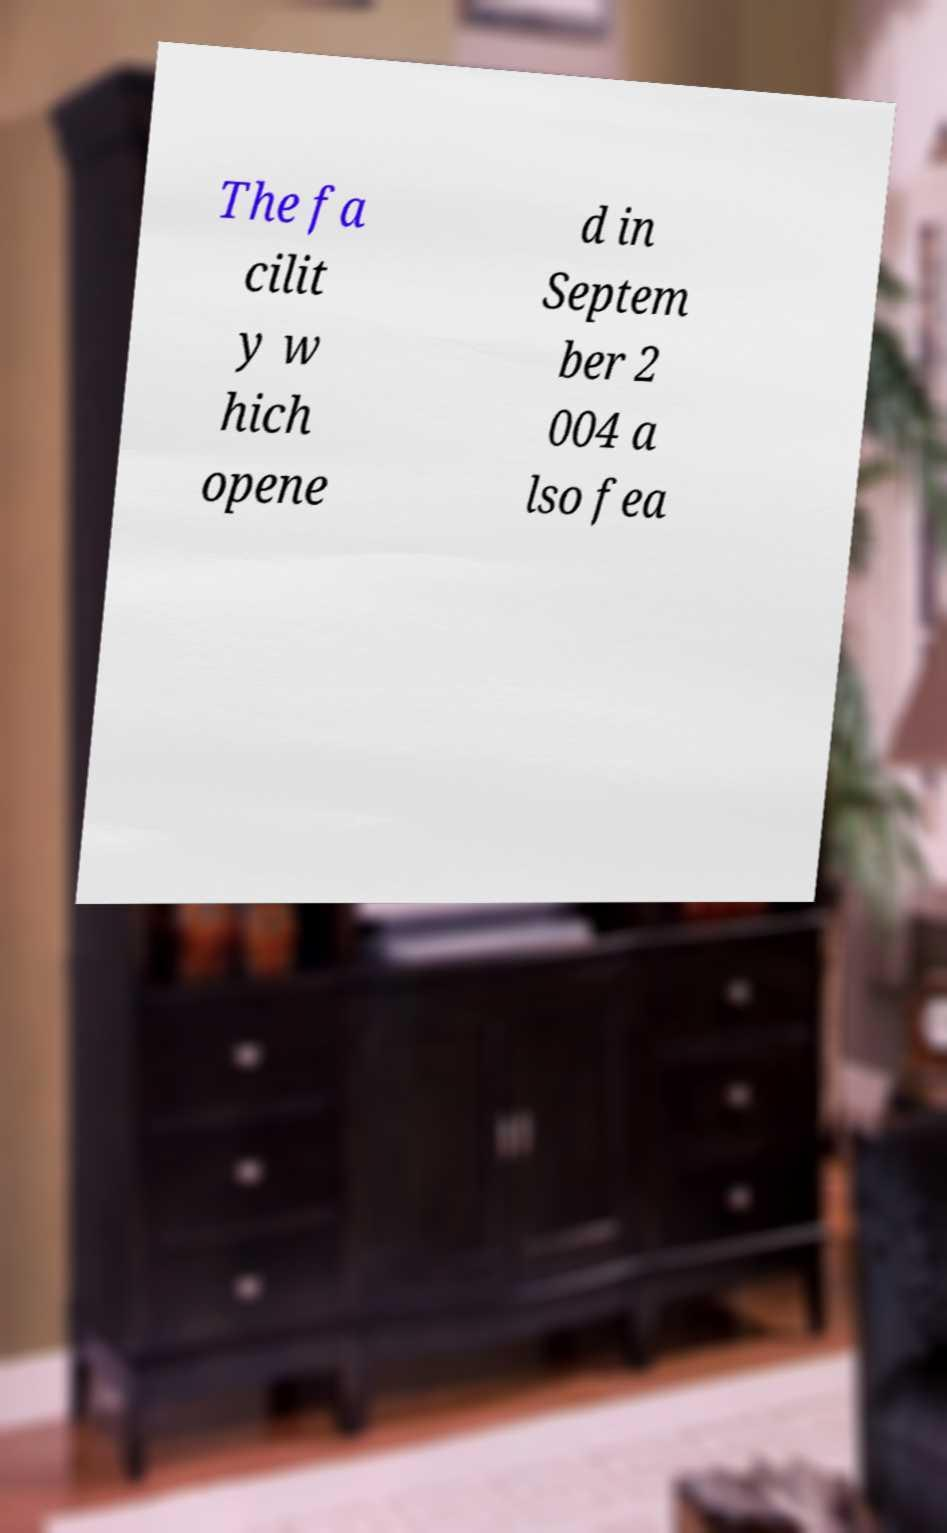Could you assist in decoding the text presented in this image and type it out clearly? The fa cilit y w hich opene d in Septem ber 2 004 a lso fea 